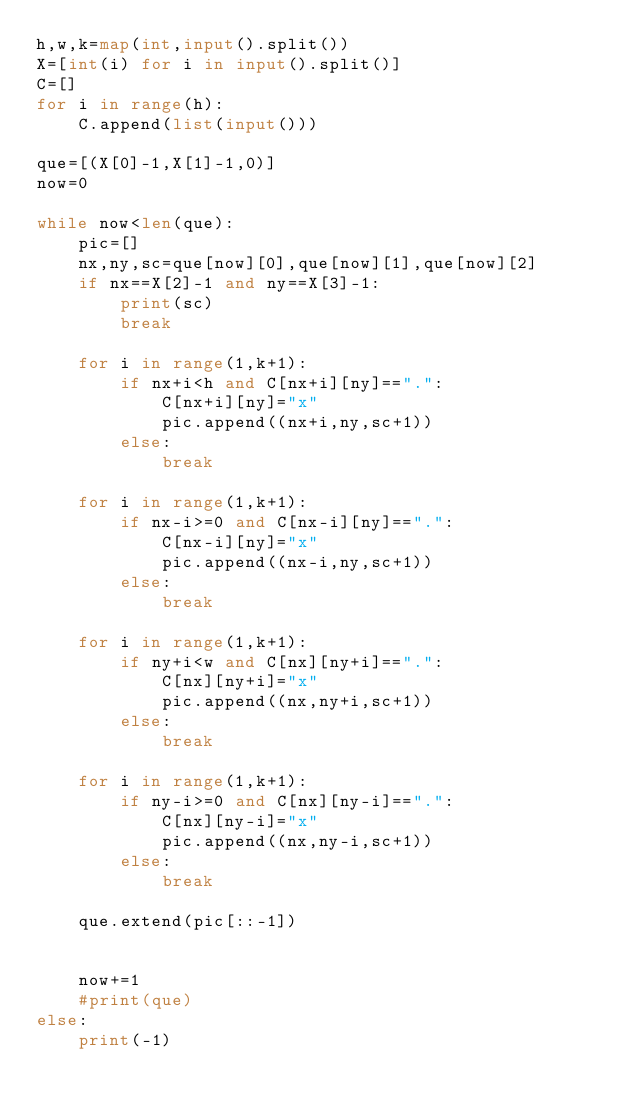<code> <loc_0><loc_0><loc_500><loc_500><_Python_>h,w,k=map(int,input().split())
X=[int(i) for i in input().split()]
C=[]
for i in range(h):
    C.append(list(input()))

que=[(X[0]-1,X[1]-1,0)]
now=0

while now<len(que):
    pic=[]
    nx,ny,sc=que[now][0],que[now][1],que[now][2]
    if nx==X[2]-1 and ny==X[3]-1:
        print(sc)
        break
    
    for i in range(1,k+1):
        if nx+i<h and C[nx+i][ny]==".":
            C[nx+i][ny]="x"
            pic.append((nx+i,ny,sc+1))
        else:
            break
        
    for i in range(1,k+1):
        if nx-i>=0 and C[nx-i][ny]==".":
            C[nx-i][ny]="x"
            pic.append((nx-i,ny,sc+1))
        else:
            break
    
    for i in range(1,k+1):
        if ny+i<w and C[nx][ny+i]==".":
            C[nx][ny+i]="x"
            pic.append((nx,ny+i,sc+1))
        else:
            break
    
    for i in range(1,k+1):
        if ny-i>=0 and C[nx][ny-i]==".":
            C[nx][ny-i]="x"
            pic.append((nx,ny-i,sc+1))
        else:
            break
    
    que.extend(pic[::-1])
    
    
    now+=1
    #print(que)
else:
    print(-1)


</code> 